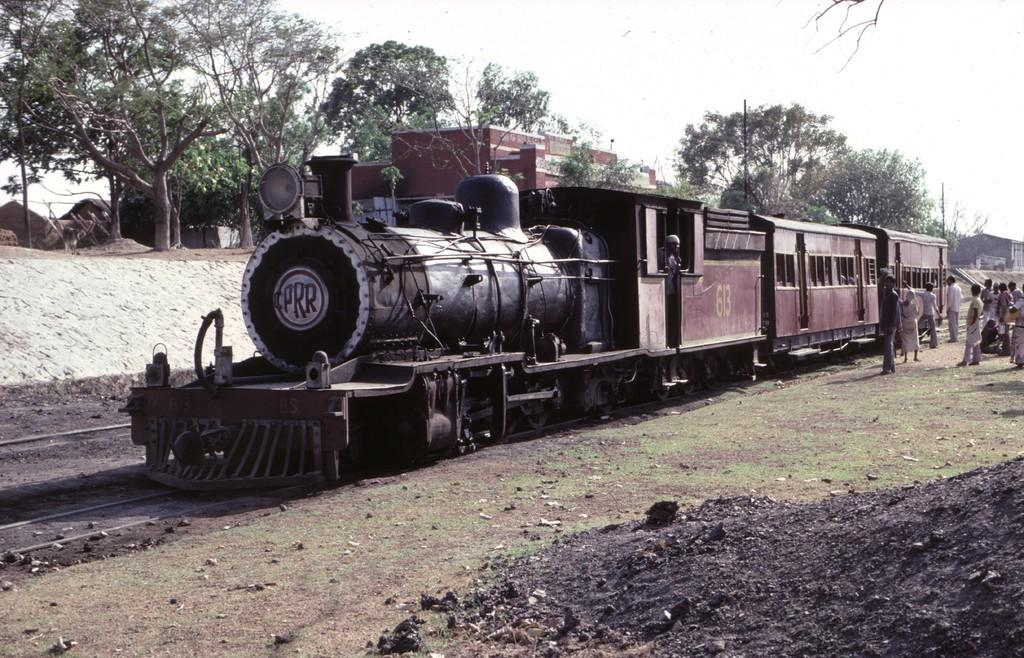What is the main subject of the image? The main subject of the image is a train. Where is the train located in the image? The train is on a track. What can be seen near the train in the image? There are people standing near the train. What type of natural environment is visible in the image? There are trees visible in the image. What type of man-made structures can be seen in the image? There are buildings in the image. What type of pear is being used as a bat by the people near the train in the image? There is no pear or bat present in the image; it features a train on a track with people standing nearby. 